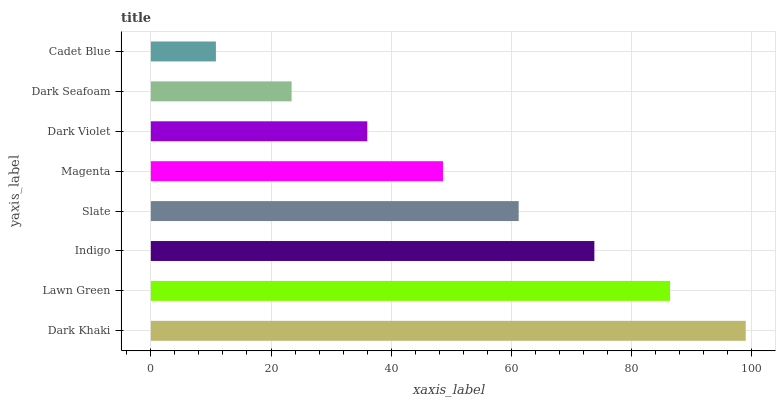Is Cadet Blue the minimum?
Answer yes or no. Yes. Is Dark Khaki the maximum?
Answer yes or no. Yes. Is Lawn Green the minimum?
Answer yes or no. No. Is Lawn Green the maximum?
Answer yes or no. No. Is Dark Khaki greater than Lawn Green?
Answer yes or no. Yes. Is Lawn Green less than Dark Khaki?
Answer yes or no. Yes. Is Lawn Green greater than Dark Khaki?
Answer yes or no. No. Is Dark Khaki less than Lawn Green?
Answer yes or no. No. Is Slate the high median?
Answer yes or no. Yes. Is Magenta the low median?
Answer yes or no. Yes. Is Cadet Blue the high median?
Answer yes or no. No. Is Dark Khaki the low median?
Answer yes or no. No. 